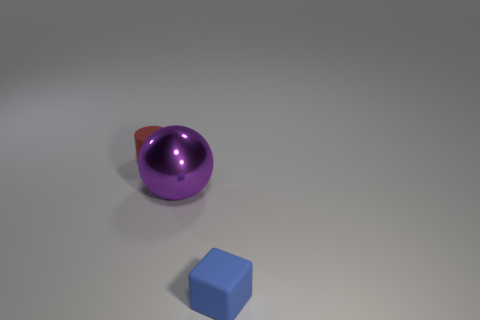Is there any other thing that has the same size as the purple metallic sphere?
Ensure brevity in your answer.  No. There is a small rubber thing that is on the left side of the ball; is there a small matte object in front of it?
Provide a short and direct response. Yes. What number of objects are either small rubber cylinders left of the shiny ball or tiny objects that are behind the block?
Provide a short and direct response. 1. What number of objects are small blue cubes or things behind the tiny blue object?
Give a very brief answer. 3. There is a matte thing in front of the tiny rubber object that is behind the small object on the right side of the red matte thing; what size is it?
Keep it short and to the point. Small. Are there any red matte cylinders that have the same size as the matte block?
Offer a very short reply. Yes. There is a matte thing that is in front of the red thing; does it have the same size as the purple metallic sphere?
Offer a terse response. No. Is the number of red things behind the purple shiny ball greater than the number of tiny gray shiny balls?
Offer a very short reply. Yes. Are there the same number of small rubber objects left of the rubber cylinder and metal objects that are in front of the small block?
Your answer should be compact. Yes. Is there anything else that is the same material as the large purple thing?
Offer a terse response. No. 